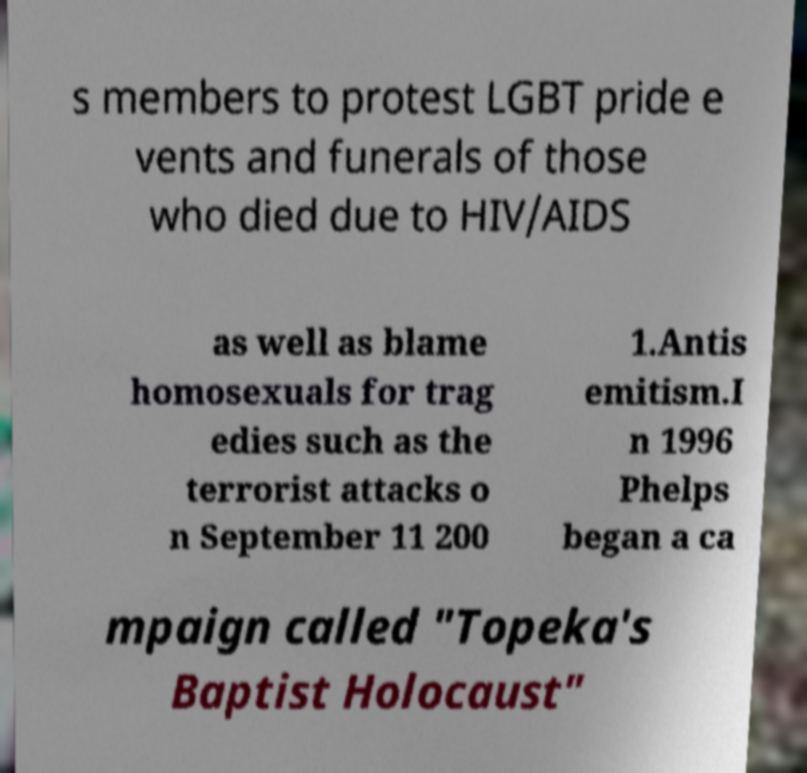Can you accurately transcribe the text from the provided image for me? s members to protest LGBT pride e vents and funerals of those who died due to HIV/AIDS as well as blame homosexuals for trag edies such as the terrorist attacks o n September 11 200 1.Antis emitism.I n 1996 Phelps began a ca mpaign called "Topeka's Baptist Holocaust" 